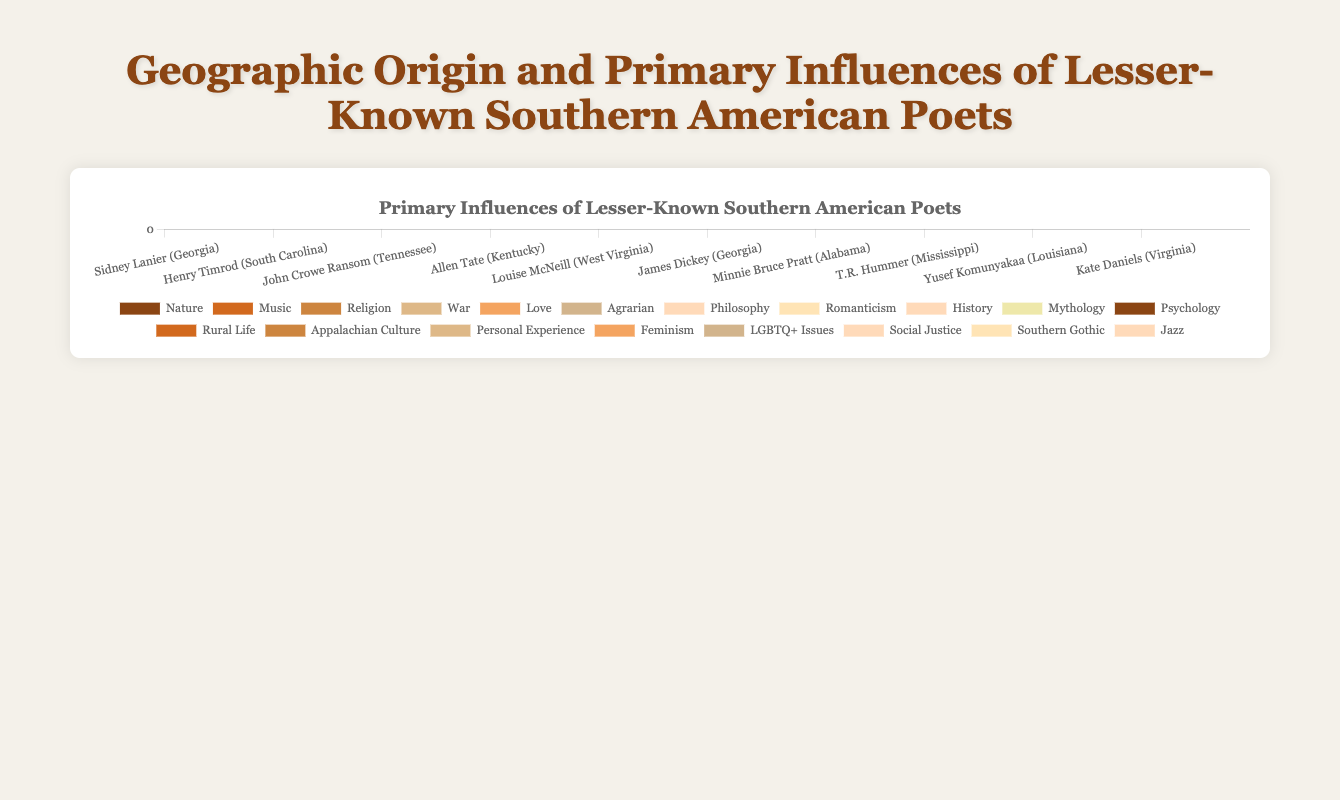Which poet has the highest influence from "Nature"? From the figure, observe the height of the "Nature" segments for each poet. Sidney Lanier has the highest influence from "Nature," comprising 60% of his influences.
Answer: Sidney Lanier Who has a greater combined influence of "War" and "Nature," Henry Timrod or James Dickey? Henry Timrod's combined influence of "War" and "Nature" is 50% (War) + 30% (Nature) = 80%. James Dickey's combined influence of "War" and "Nature" is 30% (War) + 40% (Nature) = 70%.
Answer: Henry Timrod What is the total percentage influence of "Music" across all poets? Add up the "Music" influence percentages for each poet: Sidney Lanier (30%) + T.R. Hummer (30%). The total is 30% + 30% = 60%.
Answer: 60% Which state has poets with the most varied primary influences, and what are those influences? Examine the number of different influences for poets from each state. Kentucky (Allen Tate) has three different influences (History, Mythology, Psychology), Alabama (Minnie Bruce Pratt) also has three (Feminism, LGBTQ+ Issues, Social Justice), and Georgia (Sidney Lanier and James Dickey) has four unique influences combined (Nature, Music, Religion, War, Personal Experience).
Answer: Georgia (Nature, Music, Religion, War, Personal Experience) Compare the influence of "Religion" for Sidney Lanier and Kate Daniels. Who has a higher percentage, and by how much? Sidney Lanier has a "Religion" influence of 10%, and Kate Daniels has 20%. The difference is 20% - 10% = 10%.
Answer: Kate Daniels, by 10% What influence does John Crowe Ransom have the least percentage in? From the visual comparison, "Romanticism" is the smallest segment, making up 20% of his influences.
Answer: Romanticism If we want to profile a state with poets influenced by war, which states should we include? War is significant in the influences for poets from South Carolina (Henry Timrod), Georgia (James Dickey), and Louisiana (Yusef Komunyakaa).
Answer: South Carolina, Georgia, Louisiana Which poet's influences are equally distributed among three categories? Allen Tate's influences are divided equally: History 40%, Mythology 40%, and Psychology 20%. However, they are not equal. Therefore, no poet has precisely equal distributions among three categories but Allen Tate's are closely aligned.
Answer: None What is the mean influence of "History" across poets who have it as an influence? Add the "History" influences and divide by the number of poets: Allen Tate (40%), Louise McNeill (20%), T.R. Hummer (30%). Mean = (40% + 20% + 30%) / 3 = 30%.
Answer: 30% Who is the only poet influenced by "Appalachian Culture"? Louise McNeill is the only poet with "Appalachian Culture" listed as an influence at 30%.
Answer: Louise McNeill 